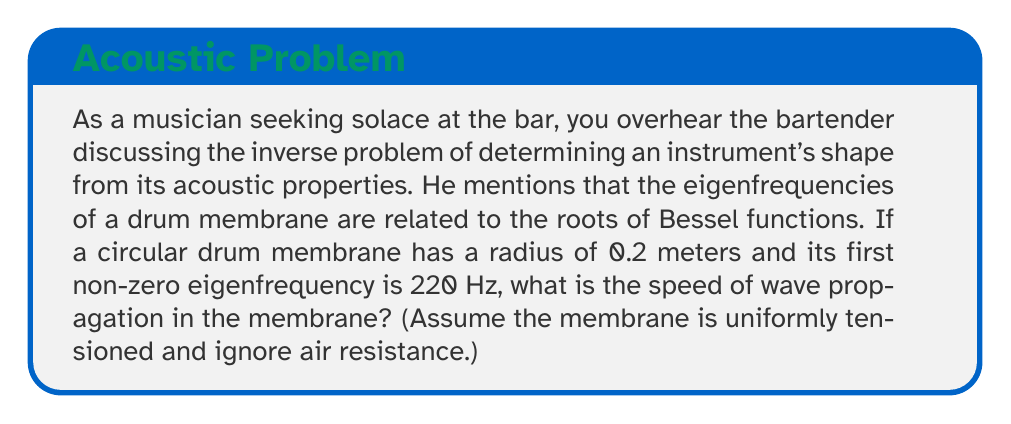Help me with this question. Let's approach this step-by-step:

1) The eigenfrequencies of a circular membrane are given by the equation:

   $$f_{mn} = \frac{c}{2\pi R} \alpha_{mn}$$

   Where:
   - $f_{mn}$ is the frequency
   - $c$ is the speed of wave propagation
   - $R$ is the radius of the membrane
   - $\alpha_{mn}$ are the roots of the Bessel function

2) For the first non-zero eigenfrequency, we use the first root of the Bessel function of the first kind:

   $$\alpha_{01} \approx 2.4048$$

3) We are given:
   - $f_{01} = 220$ Hz
   - $R = 0.2$ meters

4) Substituting these into our equation:

   $$220 = \frac{c}{2\pi(0.2)} 2.4048$$

5) Solving for $c$:

   $$c = \frac{220 \cdot 2\pi \cdot 0.2}{2.4048}$$

6) Calculating:

   $$c \approx 115.13$$ m/s
Answer: 115.13 m/s 